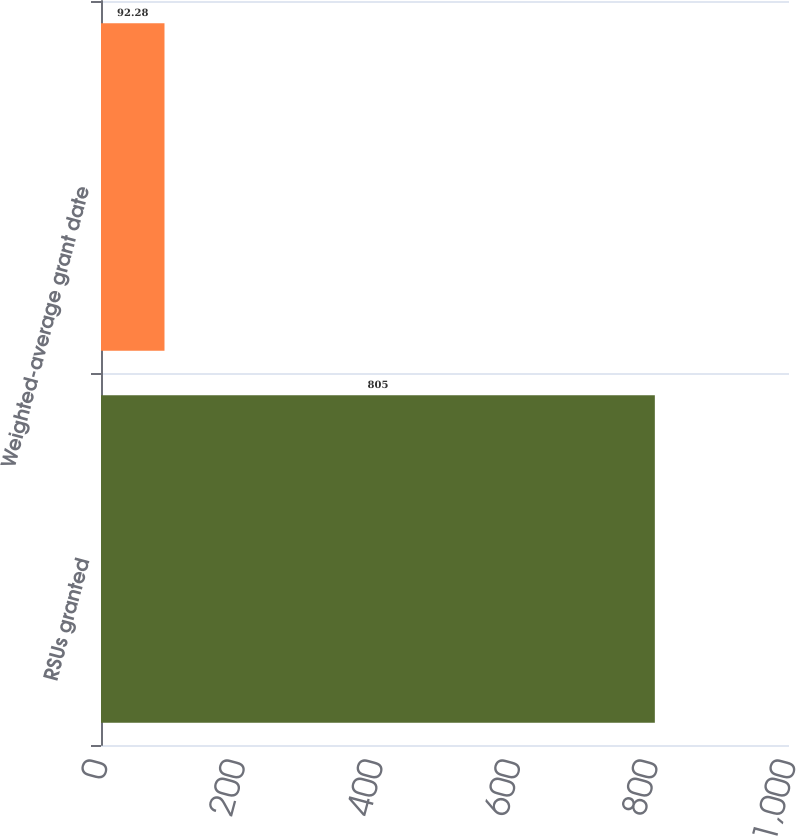Convert chart. <chart><loc_0><loc_0><loc_500><loc_500><bar_chart><fcel>RSUs granted<fcel>Weighted-average grant date<nl><fcel>805<fcel>92.28<nl></chart> 